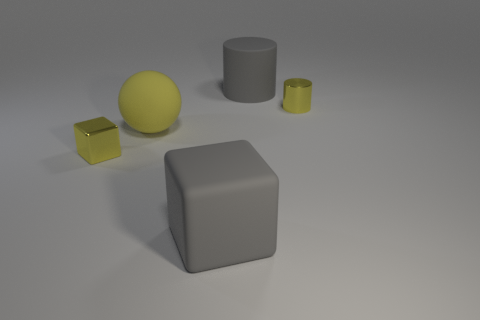What material is the yellow sphere that is the same size as the gray rubber cube?
Offer a very short reply. Rubber. What is the color of the cube left of the big gray matte object that is in front of the small yellow metallic cylinder right of the big yellow rubber object?
Your answer should be compact. Yellow. Is the shape of the yellow thing that is to the right of the large rubber block the same as the yellow metal object that is to the left of the tiny cylinder?
Your answer should be compact. No. What number of cylinders are there?
Provide a succinct answer. 2. There is a thing that is the same size as the yellow cube; what is its color?
Ensure brevity in your answer.  Yellow. Is the material of the tiny yellow object that is to the left of the large rubber cylinder the same as the gray object that is behind the big yellow matte object?
Ensure brevity in your answer.  No. What is the size of the yellow metallic thing that is behind the yellow metallic object in front of the ball?
Your response must be concise. Small. What material is the cylinder to the left of the yellow metallic cylinder?
Make the answer very short. Rubber. What number of things are gray things that are in front of the yellow block or rubber things left of the gray matte cube?
Offer a terse response. 2. Is the color of the metallic object behind the tiny block the same as the rubber cylinder that is behind the small yellow metal block?
Give a very brief answer. No. 